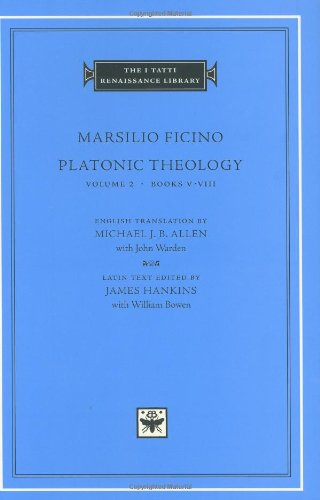Is this book related to Medical Books? No, this book is not related to medical topics. It is focused on philosophical and theological discussions, particularly those concerning the immortality of the soul and the cosmos, as seen through the lens of Neo-Platonic philosophy. 